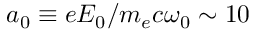Convert formula to latex. <formula><loc_0><loc_0><loc_500><loc_500>a _ { 0 } \equiv e E _ { 0 } / m _ { e } c \omega _ { 0 } \sim 1 0</formula> 